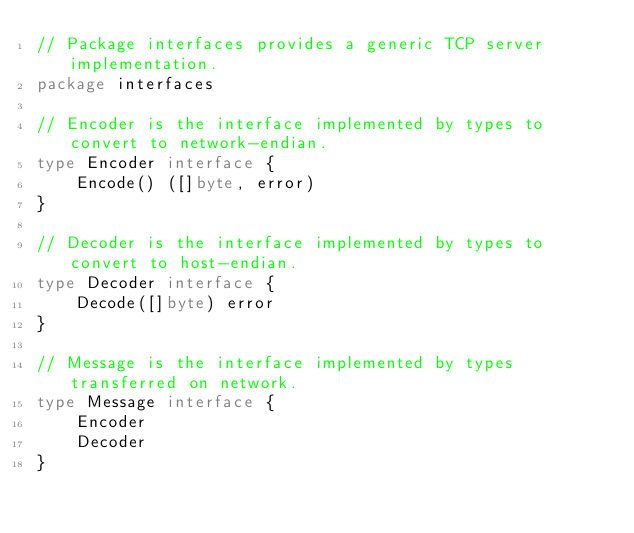Convert code to text. <code><loc_0><loc_0><loc_500><loc_500><_Go_>// Package interfaces provides a generic TCP server implementation.
package interfaces

// Encoder is the interface implemented by types to convert to network-endian.
type Encoder interface {
	Encode() ([]byte, error)
}

// Decoder is the interface implemented by types to convert to host-endian.
type Decoder interface {
	Decode([]byte) error
}

// Message is the interface implemented by types transferred on network.
type Message interface {
	Encoder
	Decoder
}
</code> 